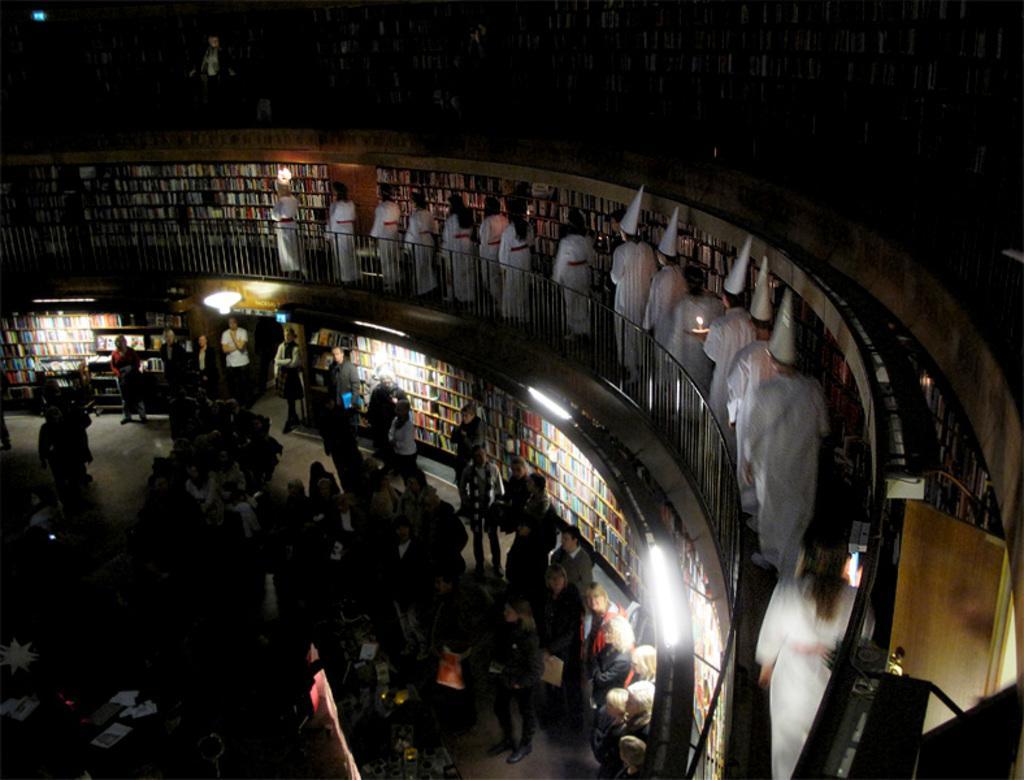Please provide a concise description of this image. In this picture we can see people wearing white dresses and standing in the balcony. Few wore caps. At the bottom we can see people and colorful walls. We can also see lights. 